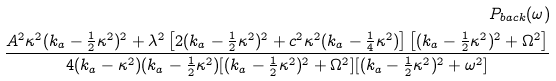Convert formula to latex. <formula><loc_0><loc_0><loc_500><loc_500>P _ { b a c k } ( \omega ) \\ \frac { A ^ { 2 } \kappa ^ { 2 } ( k _ { a } - \frac { 1 } { 2 } \kappa ^ { 2 } ) ^ { 2 } + \lambda ^ { 2 } \left [ 2 ( k _ { a } - \frac { 1 } { 2 } \kappa ^ { 2 } ) ^ { 2 } + c ^ { 2 } \kappa ^ { 2 } ( k _ { a } - \frac { 1 } { 4 } \kappa ^ { 2 } ) \right ] \left [ ( k _ { a } - \frac { 1 } { 2 } \kappa ^ { 2 } ) ^ { 2 } + \Omega ^ { 2 } \right ] } { 4 ( k _ { a } - \kappa ^ { 2 } ) ( k _ { a } - \frac { 1 } { 2 } \kappa ^ { 2 } ) [ ( k _ { a } - \frac { 1 } { 2 } \kappa ^ { 2 } ) ^ { 2 } + \Omega ^ { 2 } ] [ ( k _ { a } - \frac { 1 } { 2 } \kappa ^ { 2 } ) ^ { 2 } + \omega ^ { 2 } ] }</formula> 